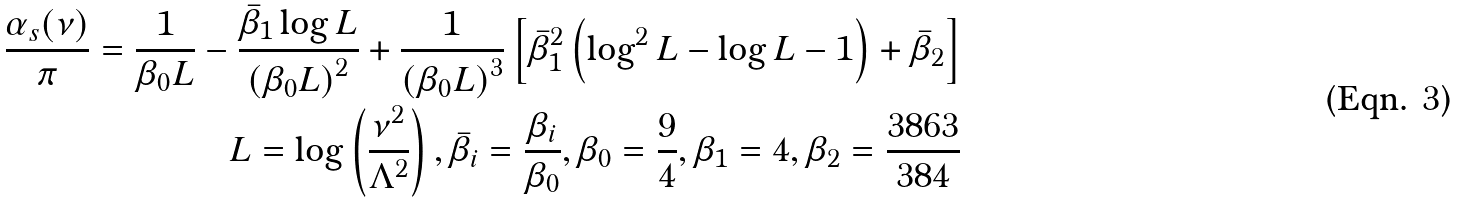Convert formula to latex. <formula><loc_0><loc_0><loc_500><loc_500>\frac { \alpha _ { s } ( \nu ) } { \pi } = \frac { 1 } { \beta _ { 0 } L } - \frac { \bar { \beta } _ { 1 } \log L } { \left ( \beta _ { 0 } L \right ) ^ { 2 } } + \frac { 1 } { \left ( \beta _ { 0 } L \right ) ^ { 3 } } \left [ \bar { \beta } _ { 1 } ^ { 2 } \left ( \log ^ { 2 } L - \log L - 1 \right ) + \bar { \beta } _ { 2 } \right ] \\ L = \log \left ( \frac { \nu ^ { 2 } } { \Lambda ^ { 2 } } \right ) , \bar { \beta } _ { i } = \frac { \beta _ { i } } { \beta _ { 0 } } , \beta _ { 0 } = \frac { 9 } { 4 } , \beta _ { 1 } = 4 , \beta _ { 2 } = \frac { 3 8 6 3 } { 3 8 4 }</formula> 